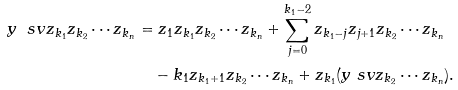<formula> <loc_0><loc_0><loc_500><loc_500>y \ s v z _ { k _ { 1 } } z _ { k _ { 2 } } \cdots z _ { k _ { n } } & = z _ { 1 } z _ { k _ { 1 } } z _ { k _ { 2 } } \cdots z _ { k _ { n } } + \sum _ { j = 0 } ^ { k _ { 1 } - 2 } z _ { k _ { 1 } - j } z _ { j + 1 } z _ { k _ { 2 } } \cdots z _ { k _ { n } } \\ & \quad - k _ { 1 } z _ { k _ { 1 } + 1 } z _ { k _ { 2 } } \cdots z _ { k _ { n } } + z _ { k _ { 1 } } ( y \ s v z _ { k _ { 2 } } \cdots z _ { k _ { n } } ) .</formula> 